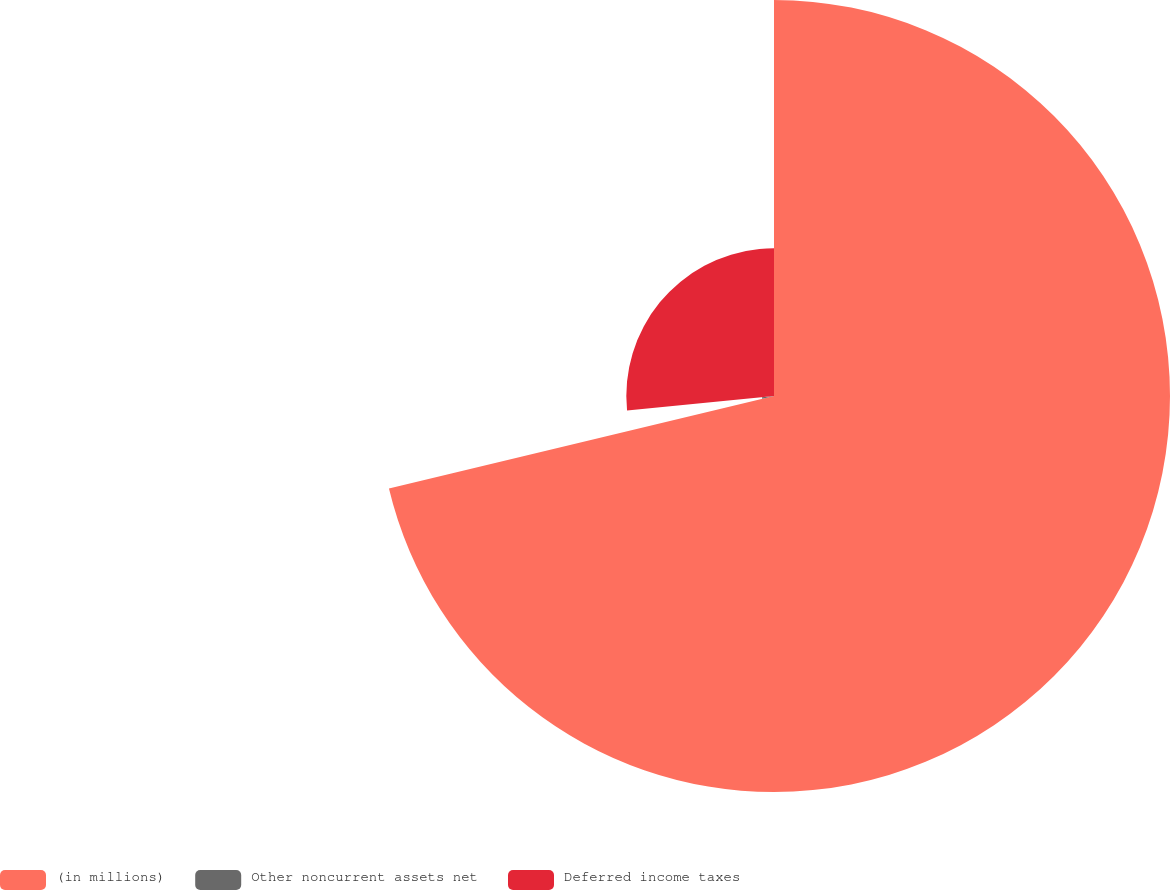Convert chart. <chart><loc_0><loc_0><loc_500><loc_500><pie_chart><fcel>(in millions)<fcel>Other noncurrent assets net<fcel>Deferred income taxes<nl><fcel>71.25%<fcel>2.18%<fcel>26.57%<nl></chart> 